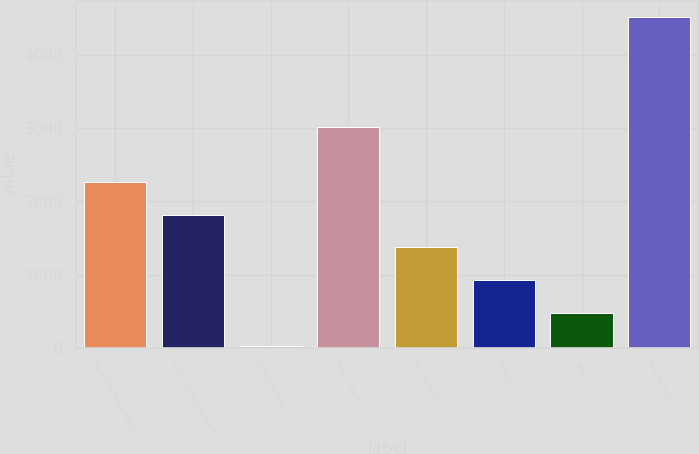<chart> <loc_0><loc_0><loc_500><loc_500><bar_chart><fcel>Xbox One PlayStation 4<fcel>Xbox 360 PlayStation 3<fcel>Other consoles<fcel>Total consoles<fcel>PC / Browser<fcel>Mobile<fcel>Other<fcel>Net revenue<nl><fcel>2268<fcel>1818.6<fcel>21<fcel>3011<fcel>1369.2<fcel>919.8<fcel>470.4<fcel>4515<nl></chart> 